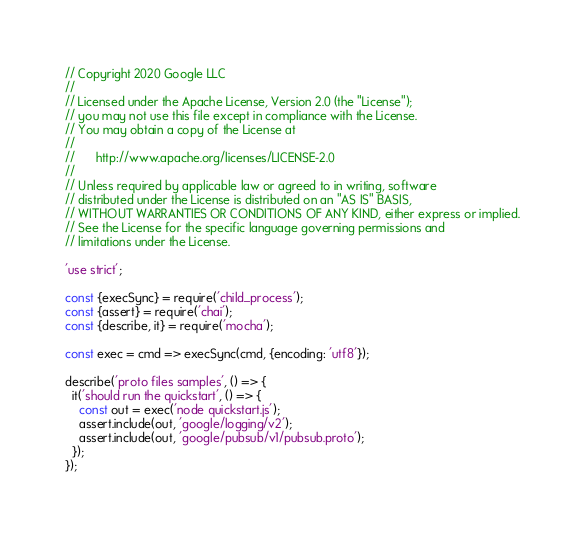Convert code to text. <code><loc_0><loc_0><loc_500><loc_500><_JavaScript_>// Copyright 2020 Google LLC
//
// Licensed under the Apache License, Version 2.0 (the "License");
// you may not use this file except in compliance with the License.
// You may obtain a copy of the License at
//
//      http://www.apache.org/licenses/LICENSE-2.0
//
// Unless required by applicable law or agreed to in writing, software
// distributed under the License is distributed on an "AS IS" BASIS,
// WITHOUT WARRANTIES OR CONDITIONS OF ANY KIND, either express or implied.
// See the License for the specific language governing permissions and
// limitations under the License.

'use strict';

const {execSync} = require('child_process');
const {assert} = require('chai');
const {describe, it} = require('mocha');

const exec = cmd => execSync(cmd, {encoding: 'utf8'});

describe('proto files samples', () => {
  it('should run the quickstart', () => {
    const out = exec('node quickstart.js');
    assert.include(out, 'google/logging/v2');
    assert.include(out, 'google/pubsub/v1/pubsub.proto');
  });
});
</code> 